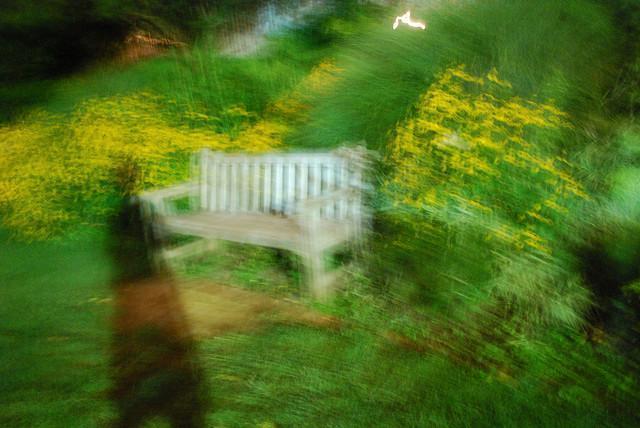How many orange cups are on the table?
Give a very brief answer. 0. 